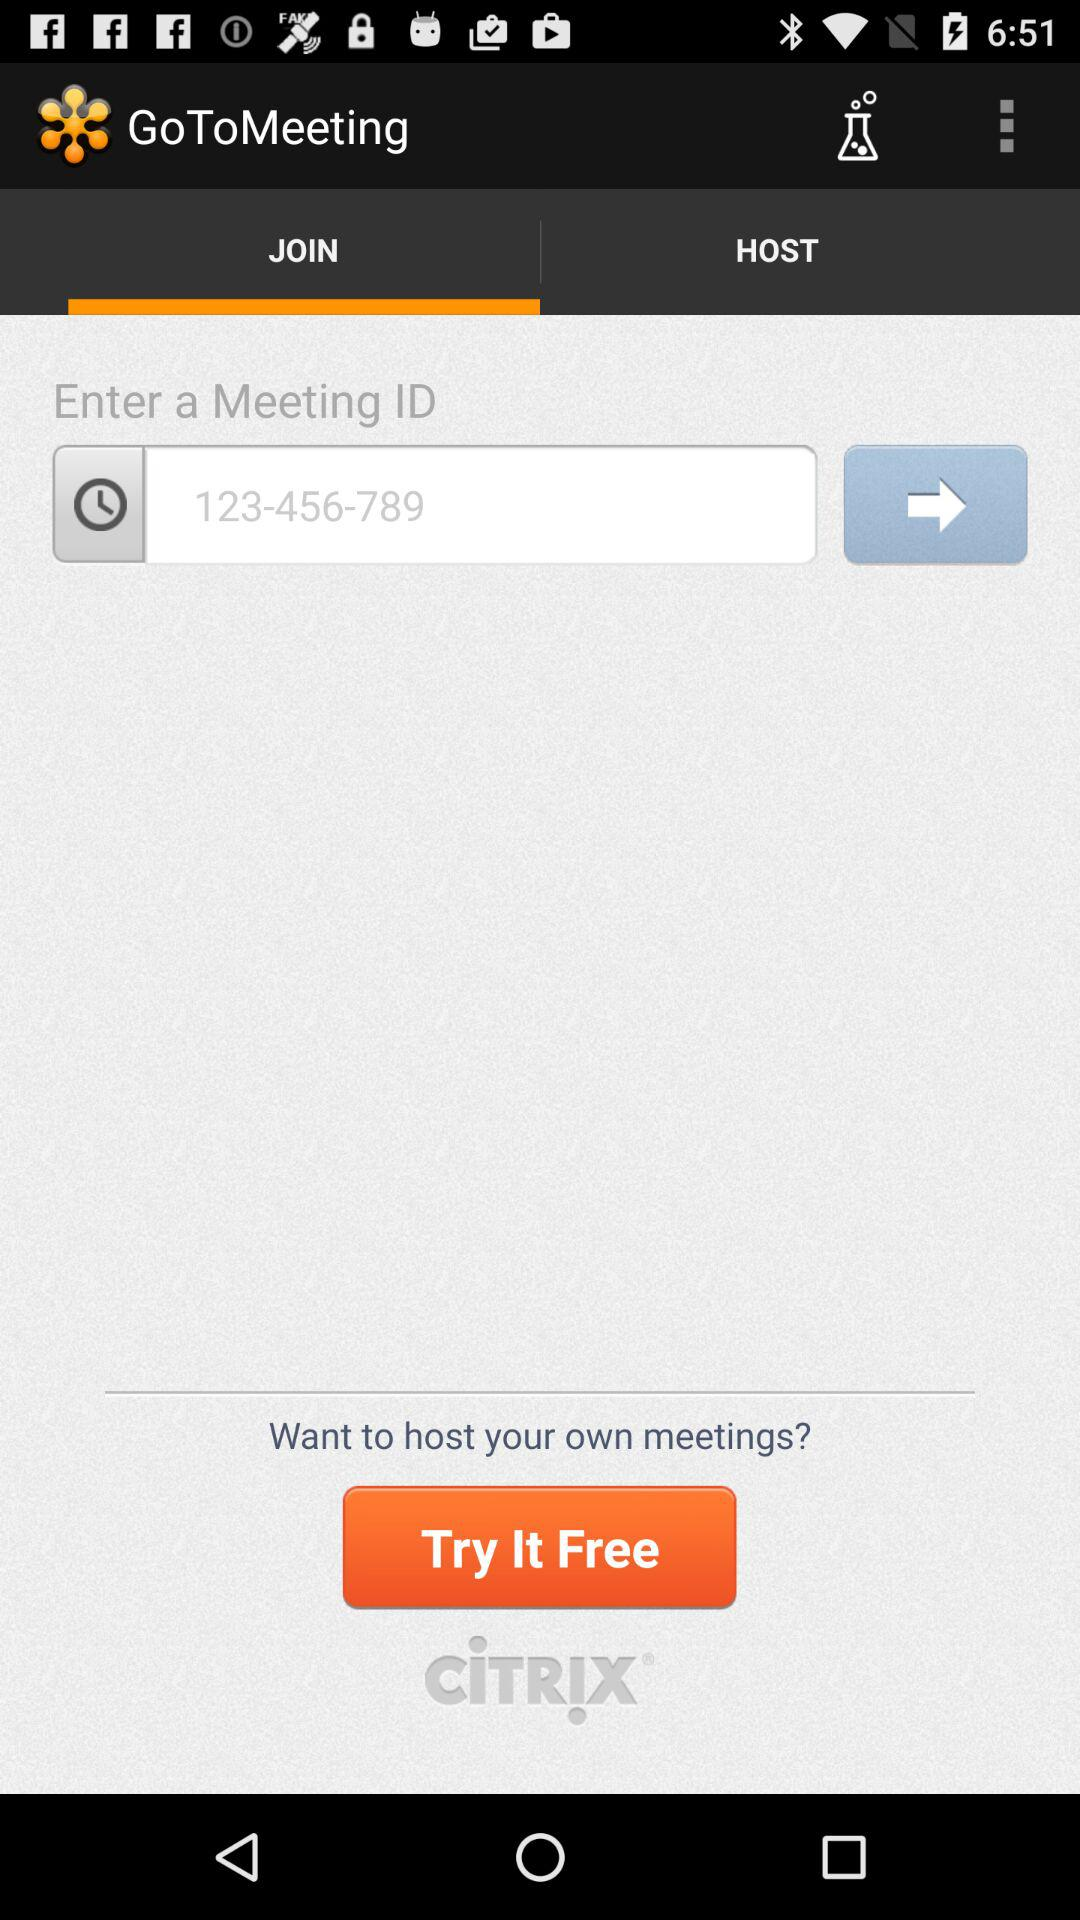What is the name of the application? The name of the application is "GoToMeeting". 